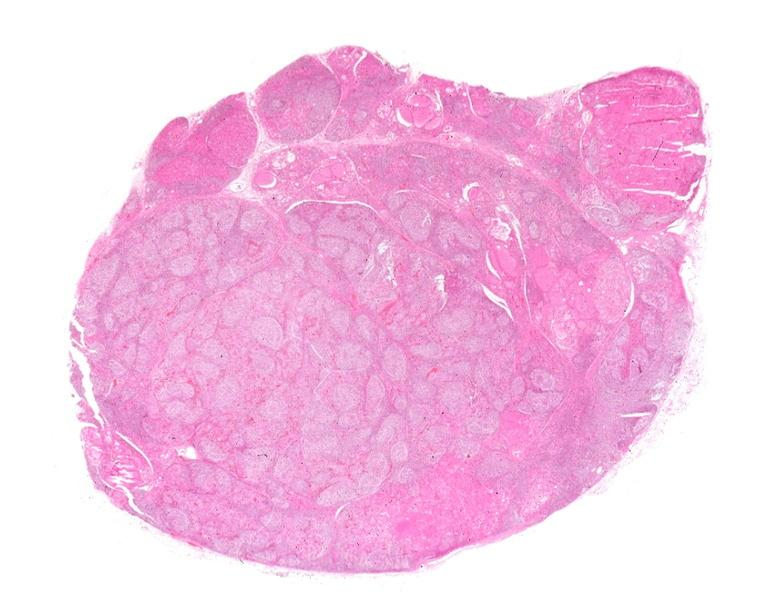does leiomyosarcoma show hashimoto 's thyroiditis?
Answer the question using a single word or phrase. No 